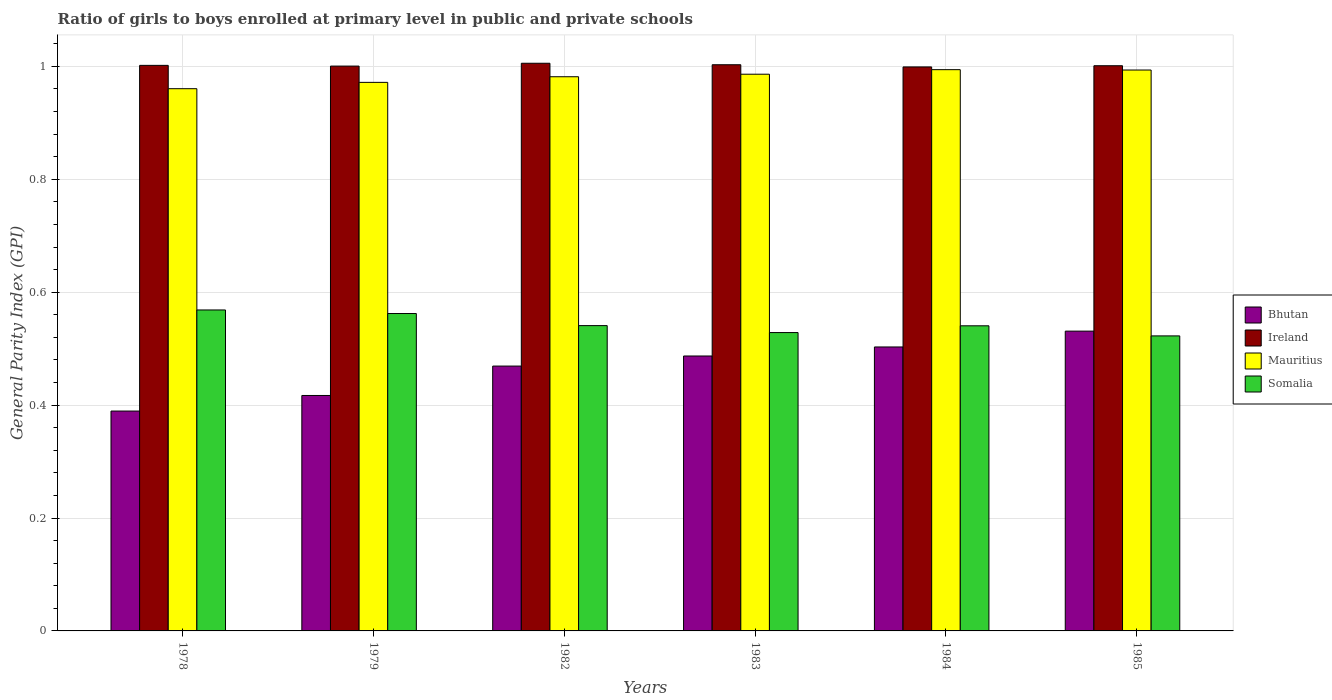How many groups of bars are there?
Keep it short and to the point. 6. How many bars are there on the 1st tick from the left?
Your response must be concise. 4. How many bars are there on the 4th tick from the right?
Make the answer very short. 4. What is the label of the 1st group of bars from the left?
Provide a short and direct response. 1978. What is the general parity index in Mauritius in 1978?
Your response must be concise. 0.96. Across all years, what is the maximum general parity index in Somalia?
Make the answer very short. 0.57. Across all years, what is the minimum general parity index in Somalia?
Give a very brief answer. 0.52. In which year was the general parity index in Ireland maximum?
Ensure brevity in your answer.  1982. In which year was the general parity index in Bhutan minimum?
Ensure brevity in your answer.  1978. What is the total general parity index in Somalia in the graph?
Offer a terse response. 3.26. What is the difference between the general parity index in Bhutan in 1978 and that in 1982?
Provide a succinct answer. -0.08. What is the difference between the general parity index in Ireland in 1982 and the general parity index in Somalia in 1985?
Give a very brief answer. 0.48. What is the average general parity index in Ireland per year?
Keep it short and to the point. 1. In the year 1984, what is the difference between the general parity index in Bhutan and general parity index in Ireland?
Give a very brief answer. -0.5. What is the ratio of the general parity index in Ireland in 1978 to that in 1984?
Provide a short and direct response. 1. Is the difference between the general parity index in Bhutan in 1978 and 1984 greater than the difference between the general parity index in Ireland in 1978 and 1984?
Make the answer very short. No. What is the difference between the highest and the second highest general parity index in Ireland?
Provide a short and direct response. 0. What is the difference between the highest and the lowest general parity index in Bhutan?
Keep it short and to the point. 0.14. In how many years, is the general parity index in Ireland greater than the average general parity index in Ireland taken over all years?
Your answer should be very brief. 2. Is it the case that in every year, the sum of the general parity index in Ireland and general parity index in Mauritius is greater than the sum of general parity index in Somalia and general parity index in Bhutan?
Keep it short and to the point. No. What does the 3rd bar from the left in 1979 represents?
Provide a succinct answer. Mauritius. What does the 2nd bar from the right in 1983 represents?
Your response must be concise. Mauritius. Is it the case that in every year, the sum of the general parity index in Ireland and general parity index in Mauritius is greater than the general parity index in Bhutan?
Keep it short and to the point. Yes. How many bars are there?
Offer a very short reply. 24. Are all the bars in the graph horizontal?
Make the answer very short. No. How many years are there in the graph?
Your answer should be compact. 6. Does the graph contain grids?
Offer a terse response. Yes. How are the legend labels stacked?
Ensure brevity in your answer.  Vertical. What is the title of the graph?
Ensure brevity in your answer.  Ratio of girls to boys enrolled at primary level in public and private schools. What is the label or title of the Y-axis?
Your response must be concise. General Parity Index (GPI). What is the General Parity Index (GPI) of Bhutan in 1978?
Offer a terse response. 0.39. What is the General Parity Index (GPI) in Ireland in 1978?
Provide a short and direct response. 1. What is the General Parity Index (GPI) of Mauritius in 1978?
Your answer should be compact. 0.96. What is the General Parity Index (GPI) in Somalia in 1978?
Ensure brevity in your answer.  0.57. What is the General Parity Index (GPI) of Bhutan in 1979?
Keep it short and to the point. 0.42. What is the General Parity Index (GPI) of Ireland in 1979?
Your answer should be very brief. 1. What is the General Parity Index (GPI) in Mauritius in 1979?
Offer a terse response. 0.97. What is the General Parity Index (GPI) in Somalia in 1979?
Give a very brief answer. 0.56. What is the General Parity Index (GPI) in Bhutan in 1982?
Make the answer very short. 0.47. What is the General Parity Index (GPI) in Ireland in 1982?
Your answer should be very brief. 1.01. What is the General Parity Index (GPI) of Mauritius in 1982?
Your answer should be very brief. 0.98. What is the General Parity Index (GPI) of Somalia in 1982?
Provide a succinct answer. 0.54. What is the General Parity Index (GPI) of Bhutan in 1983?
Your answer should be very brief. 0.49. What is the General Parity Index (GPI) of Ireland in 1983?
Your answer should be very brief. 1. What is the General Parity Index (GPI) of Mauritius in 1983?
Provide a succinct answer. 0.99. What is the General Parity Index (GPI) in Somalia in 1983?
Your response must be concise. 0.53. What is the General Parity Index (GPI) in Bhutan in 1984?
Ensure brevity in your answer.  0.5. What is the General Parity Index (GPI) of Ireland in 1984?
Your response must be concise. 1. What is the General Parity Index (GPI) of Mauritius in 1984?
Keep it short and to the point. 0.99. What is the General Parity Index (GPI) in Somalia in 1984?
Offer a very short reply. 0.54. What is the General Parity Index (GPI) of Bhutan in 1985?
Your answer should be compact. 0.53. What is the General Parity Index (GPI) of Ireland in 1985?
Keep it short and to the point. 1. What is the General Parity Index (GPI) of Mauritius in 1985?
Give a very brief answer. 0.99. What is the General Parity Index (GPI) of Somalia in 1985?
Your answer should be compact. 0.52. Across all years, what is the maximum General Parity Index (GPI) in Bhutan?
Your answer should be compact. 0.53. Across all years, what is the maximum General Parity Index (GPI) in Ireland?
Your response must be concise. 1.01. Across all years, what is the maximum General Parity Index (GPI) in Mauritius?
Make the answer very short. 0.99. Across all years, what is the maximum General Parity Index (GPI) of Somalia?
Keep it short and to the point. 0.57. Across all years, what is the minimum General Parity Index (GPI) in Bhutan?
Provide a short and direct response. 0.39. Across all years, what is the minimum General Parity Index (GPI) in Ireland?
Make the answer very short. 1. Across all years, what is the minimum General Parity Index (GPI) in Mauritius?
Your answer should be compact. 0.96. Across all years, what is the minimum General Parity Index (GPI) in Somalia?
Offer a terse response. 0.52. What is the total General Parity Index (GPI) of Bhutan in the graph?
Your answer should be compact. 2.8. What is the total General Parity Index (GPI) in Ireland in the graph?
Give a very brief answer. 6.01. What is the total General Parity Index (GPI) in Mauritius in the graph?
Ensure brevity in your answer.  5.89. What is the total General Parity Index (GPI) in Somalia in the graph?
Your answer should be very brief. 3.26. What is the difference between the General Parity Index (GPI) of Bhutan in 1978 and that in 1979?
Make the answer very short. -0.03. What is the difference between the General Parity Index (GPI) of Ireland in 1978 and that in 1979?
Ensure brevity in your answer.  0. What is the difference between the General Parity Index (GPI) of Mauritius in 1978 and that in 1979?
Offer a terse response. -0.01. What is the difference between the General Parity Index (GPI) of Somalia in 1978 and that in 1979?
Your answer should be very brief. 0.01. What is the difference between the General Parity Index (GPI) in Bhutan in 1978 and that in 1982?
Offer a very short reply. -0.08. What is the difference between the General Parity Index (GPI) in Ireland in 1978 and that in 1982?
Provide a succinct answer. -0. What is the difference between the General Parity Index (GPI) in Mauritius in 1978 and that in 1982?
Ensure brevity in your answer.  -0.02. What is the difference between the General Parity Index (GPI) of Somalia in 1978 and that in 1982?
Your response must be concise. 0.03. What is the difference between the General Parity Index (GPI) in Bhutan in 1978 and that in 1983?
Ensure brevity in your answer.  -0.1. What is the difference between the General Parity Index (GPI) in Ireland in 1978 and that in 1983?
Ensure brevity in your answer.  -0. What is the difference between the General Parity Index (GPI) of Mauritius in 1978 and that in 1983?
Make the answer very short. -0.03. What is the difference between the General Parity Index (GPI) in Bhutan in 1978 and that in 1984?
Your response must be concise. -0.11. What is the difference between the General Parity Index (GPI) in Ireland in 1978 and that in 1984?
Offer a very short reply. 0. What is the difference between the General Parity Index (GPI) of Mauritius in 1978 and that in 1984?
Your answer should be compact. -0.03. What is the difference between the General Parity Index (GPI) in Somalia in 1978 and that in 1984?
Your response must be concise. 0.03. What is the difference between the General Parity Index (GPI) in Bhutan in 1978 and that in 1985?
Provide a succinct answer. -0.14. What is the difference between the General Parity Index (GPI) in Ireland in 1978 and that in 1985?
Your response must be concise. 0. What is the difference between the General Parity Index (GPI) in Mauritius in 1978 and that in 1985?
Your answer should be very brief. -0.03. What is the difference between the General Parity Index (GPI) in Somalia in 1978 and that in 1985?
Provide a short and direct response. 0.05. What is the difference between the General Parity Index (GPI) of Bhutan in 1979 and that in 1982?
Offer a terse response. -0.05. What is the difference between the General Parity Index (GPI) of Ireland in 1979 and that in 1982?
Provide a short and direct response. -0.01. What is the difference between the General Parity Index (GPI) in Mauritius in 1979 and that in 1982?
Give a very brief answer. -0.01. What is the difference between the General Parity Index (GPI) of Somalia in 1979 and that in 1982?
Give a very brief answer. 0.02. What is the difference between the General Parity Index (GPI) in Bhutan in 1979 and that in 1983?
Provide a short and direct response. -0.07. What is the difference between the General Parity Index (GPI) of Ireland in 1979 and that in 1983?
Your answer should be very brief. -0. What is the difference between the General Parity Index (GPI) in Mauritius in 1979 and that in 1983?
Your answer should be very brief. -0.01. What is the difference between the General Parity Index (GPI) of Somalia in 1979 and that in 1983?
Your answer should be compact. 0.03. What is the difference between the General Parity Index (GPI) in Bhutan in 1979 and that in 1984?
Make the answer very short. -0.09. What is the difference between the General Parity Index (GPI) in Ireland in 1979 and that in 1984?
Make the answer very short. 0. What is the difference between the General Parity Index (GPI) in Mauritius in 1979 and that in 1984?
Your response must be concise. -0.02. What is the difference between the General Parity Index (GPI) in Somalia in 1979 and that in 1984?
Give a very brief answer. 0.02. What is the difference between the General Parity Index (GPI) in Bhutan in 1979 and that in 1985?
Your answer should be very brief. -0.11. What is the difference between the General Parity Index (GPI) in Ireland in 1979 and that in 1985?
Offer a very short reply. -0. What is the difference between the General Parity Index (GPI) of Mauritius in 1979 and that in 1985?
Your answer should be very brief. -0.02. What is the difference between the General Parity Index (GPI) of Somalia in 1979 and that in 1985?
Give a very brief answer. 0.04. What is the difference between the General Parity Index (GPI) in Bhutan in 1982 and that in 1983?
Give a very brief answer. -0.02. What is the difference between the General Parity Index (GPI) in Ireland in 1982 and that in 1983?
Your answer should be very brief. 0. What is the difference between the General Parity Index (GPI) in Mauritius in 1982 and that in 1983?
Ensure brevity in your answer.  -0. What is the difference between the General Parity Index (GPI) in Somalia in 1982 and that in 1983?
Your answer should be very brief. 0.01. What is the difference between the General Parity Index (GPI) of Bhutan in 1982 and that in 1984?
Offer a very short reply. -0.03. What is the difference between the General Parity Index (GPI) of Ireland in 1982 and that in 1984?
Offer a very short reply. 0.01. What is the difference between the General Parity Index (GPI) of Mauritius in 1982 and that in 1984?
Give a very brief answer. -0.01. What is the difference between the General Parity Index (GPI) of Bhutan in 1982 and that in 1985?
Your answer should be compact. -0.06. What is the difference between the General Parity Index (GPI) in Ireland in 1982 and that in 1985?
Keep it short and to the point. 0. What is the difference between the General Parity Index (GPI) in Mauritius in 1982 and that in 1985?
Provide a short and direct response. -0.01. What is the difference between the General Parity Index (GPI) of Somalia in 1982 and that in 1985?
Your response must be concise. 0.02. What is the difference between the General Parity Index (GPI) in Bhutan in 1983 and that in 1984?
Your answer should be very brief. -0.02. What is the difference between the General Parity Index (GPI) in Ireland in 1983 and that in 1984?
Provide a succinct answer. 0. What is the difference between the General Parity Index (GPI) of Mauritius in 1983 and that in 1984?
Your answer should be compact. -0.01. What is the difference between the General Parity Index (GPI) in Somalia in 1983 and that in 1984?
Your answer should be compact. -0.01. What is the difference between the General Parity Index (GPI) in Bhutan in 1983 and that in 1985?
Your answer should be very brief. -0.04. What is the difference between the General Parity Index (GPI) of Ireland in 1983 and that in 1985?
Make the answer very short. 0. What is the difference between the General Parity Index (GPI) of Mauritius in 1983 and that in 1985?
Make the answer very short. -0.01. What is the difference between the General Parity Index (GPI) in Somalia in 1983 and that in 1985?
Offer a terse response. 0.01. What is the difference between the General Parity Index (GPI) of Bhutan in 1984 and that in 1985?
Offer a very short reply. -0.03. What is the difference between the General Parity Index (GPI) of Ireland in 1984 and that in 1985?
Make the answer very short. -0. What is the difference between the General Parity Index (GPI) of Mauritius in 1984 and that in 1985?
Your answer should be compact. 0. What is the difference between the General Parity Index (GPI) of Somalia in 1984 and that in 1985?
Your answer should be very brief. 0.02. What is the difference between the General Parity Index (GPI) in Bhutan in 1978 and the General Parity Index (GPI) in Ireland in 1979?
Offer a terse response. -0.61. What is the difference between the General Parity Index (GPI) of Bhutan in 1978 and the General Parity Index (GPI) of Mauritius in 1979?
Give a very brief answer. -0.58. What is the difference between the General Parity Index (GPI) of Bhutan in 1978 and the General Parity Index (GPI) of Somalia in 1979?
Your answer should be very brief. -0.17. What is the difference between the General Parity Index (GPI) in Ireland in 1978 and the General Parity Index (GPI) in Mauritius in 1979?
Your answer should be very brief. 0.03. What is the difference between the General Parity Index (GPI) in Ireland in 1978 and the General Parity Index (GPI) in Somalia in 1979?
Ensure brevity in your answer.  0.44. What is the difference between the General Parity Index (GPI) in Mauritius in 1978 and the General Parity Index (GPI) in Somalia in 1979?
Offer a very short reply. 0.4. What is the difference between the General Parity Index (GPI) in Bhutan in 1978 and the General Parity Index (GPI) in Ireland in 1982?
Keep it short and to the point. -0.62. What is the difference between the General Parity Index (GPI) of Bhutan in 1978 and the General Parity Index (GPI) of Mauritius in 1982?
Your answer should be very brief. -0.59. What is the difference between the General Parity Index (GPI) in Bhutan in 1978 and the General Parity Index (GPI) in Somalia in 1982?
Offer a very short reply. -0.15. What is the difference between the General Parity Index (GPI) in Ireland in 1978 and the General Parity Index (GPI) in Mauritius in 1982?
Offer a terse response. 0.02. What is the difference between the General Parity Index (GPI) in Ireland in 1978 and the General Parity Index (GPI) in Somalia in 1982?
Give a very brief answer. 0.46. What is the difference between the General Parity Index (GPI) in Mauritius in 1978 and the General Parity Index (GPI) in Somalia in 1982?
Give a very brief answer. 0.42. What is the difference between the General Parity Index (GPI) in Bhutan in 1978 and the General Parity Index (GPI) in Ireland in 1983?
Offer a terse response. -0.61. What is the difference between the General Parity Index (GPI) of Bhutan in 1978 and the General Parity Index (GPI) of Mauritius in 1983?
Provide a short and direct response. -0.6. What is the difference between the General Parity Index (GPI) of Bhutan in 1978 and the General Parity Index (GPI) of Somalia in 1983?
Keep it short and to the point. -0.14. What is the difference between the General Parity Index (GPI) in Ireland in 1978 and the General Parity Index (GPI) in Mauritius in 1983?
Your answer should be very brief. 0.02. What is the difference between the General Parity Index (GPI) in Ireland in 1978 and the General Parity Index (GPI) in Somalia in 1983?
Ensure brevity in your answer.  0.47. What is the difference between the General Parity Index (GPI) of Mauritius in 1978 and the General Parity Index (GPI) of Somalia in 1983?
Your answer should be compact. 0.43. What is the difference between the General Parity Index (GPI) in Bhutan in 1978 and the General Parity Index (GPI) in Ireland in 1984?
Give a very brief answer. -0.61. What is the difference between the General Parity Index (GPI) of Bhutan in 1978 and the General Parity Index (GPI) of Mauritius in 1984?
Make the answer very short. -0.6. What is the difference between the General Parity Index (GPI) in Bhutan in 1978 and the General Parity Index (GPI) in Somalia in 1984?
Offer a terse response. -0.15. What is the difference between the General Parity Index (GPI) of Ireland in 1978 and the General Parity Index (GPI) of Mauritius in 1984?
Provide a short and direct response. 0.01. What is the difference between the General Parity Index (GPI) in Ireland in 1978 and the General Parity Index (GPI) in Somalia in 1984?
Your answer should be compact. 0.46. What is the difference between the General Parity Index (GPI) in Mauritius in 1978 and the General Parity Index (GPI) in Somalia in 1984?
Provide a short and direct response. 0.42. What is the difference between the General Parity Index (GPI) of Bhutan in 1978 and the General Parity Index (GPI) of Ireland in 1985?
Offer a terse response. -0.61. What is the difference between the General Parity Index (GPI) of Bhutan in 1978 and the General Parity Index (GPI) of Mauritius in 1985?
Make the answer very short. -0.6. What is the difference between the General Parity Index (GPI) of Bhutan in 1978 and the General Parity Index (GPI) of Somalia in 1985?
Ensure brevity in your answer.  -0.13. What is the difference between the General Parity Index (GPI) of Ireland in 1978 and the General Parity Index (GPI) of Mauritius in 1985?
Give a very brief answer. 0.01. What is the difference between the General Parity Index (GPI) of Ireland in 1978 and the General Parity Index (GPI) of Somalia in 1985?
Make the answer very short. 0.48. What is the difference between the General Parity Index (GPI) of Mauritius in 1978 and the General Parity Index (GPI) of Somalia in 1985?
Offer a very short reply. 0.44. What is the difference between the General Parity Index (GPI) in Bhutan in 1979 and the General Parity Index (GPI) in Ireland in 1982?
Make the answer very short. -0.59. What is the difference between the General Parity Index (GPI) of Bhutan in 1979 and the General Parity Index (GPI) of Mauritius in 1982?
Your answer should be very brief. -0.56. What is the difference between the General Parity Index (GPI) in Bhutan in 1979 and the General Parity Index (GPI) in Somalia in 1982?
Offer a terse response. -0.12. What is the difference between the General Parity Index (GPI) in Ireland in 1979 and the General Parity Index (GPI) in Mauritius in 1982?
Offer a terse response. 0.02. What is the difference between the General Parity Index (GPI) of Ireland in 1979 and the General Parity Index (GPI) of Somalia in 1982?
Provide a short and direct response. 0.46. What is the difference between the General Parity Index (GPI) in Mauritius in 1979 and the General Parity Index (GPI) in Somalia in 1982?
Ensure brevity in your answer.  0.43. What is the difference between the General Parity Index (GPI) of Bhutan in 1979 and the General Parity Index (GPI) of Ireland in 1983?
Keep it short and to the point. -0.59. What is the difference between the General Parity Index (GPI) of Bhutan in 1979 and the General Parity Index (GPI) of Mauritius in 1983?
Make the answer very short. -0.57. What is the difference between the General Parity Index (GPI) in Bhutan in 1979 and the General Parity Index (GPI) in Somalia in 1983?
Keep it short and to the point. -0.11. What is the difference between the General Parity Index (GPI) of Ireland in 1979 and the General Parity Index (GPI) of Mauritius in 1983?
Ensure brevity in your answer.  0.01. What is the difference between the General Parity Index (GPI) of Ireland in 1979 and the General Parity Index (GPI) of Somalia in 1983?
Give a very brief answer. 0.47. What is the difference between the General Parity Index (GPI) in Mauritius in 1979 and the General Parity Index (GPI) in Somalia in 1983?
Keep it short and to the point. 0.44. What is the difference between the General Parity Index (GPI) of Bhutan in 1979 and the General Parity Index (GPI) of Ireland in 1984?
Make the answer very short. -0.58. What is the difference between the General Parity Index (GPI) in Bhutan in 1979 and the General Parity Index (GPI) in Mauritius in 1984?
Your response must be concise. -0.58. What is the difference between the General Parity Index (GPI) in Bhutan in 1979 and the General Parity Index (GPI) in Somalia in 1984?
Provide a succinct answer. -0.12. What is the difference between the General Parity Index (GPI) in Ireland in 1979 and the General Parity Index (GPI) in Mauritius in 1984?
Keep it short and to the point. 0.01. What is the difference between the General Parity Index (GPI) of Ireland in 1979 and the General Parity Index (GPI) of Somalia in 1984?
Ensure brevity in your answer.  0.46. What is the difference between the General Parity Index (GPI) in Mauritius in 1979 and the General Parity Index (GPI) in Somalia in 1984?
Provide a short and direct response. 0.43. What is the difference between the General Parity Index (GPI) of Bhutan in 1979 and the General Parity Index (GPI) of Ireland in 1985?
Your answer should be compact. -0.58. What is the difference between the General Parity Index (GPI) in Bhutan in 1979 and the General Parity Index (GPI) in Mauritius in 1985?
Offer a terse response. -0.58. What is the difference between the General Parity Index (GPI) in Bhutan in 1979 and the General Parity Index (GPI) in Somalia in 1985?
Your answer should be compact. -0.11. What is the difference between the General Parity Index (GPI) of Ireland in 1979 and the General Parity Index (GPI) of Mauritius in 1985?
Ensure brevity in your answer.  0.01. What is the difference between the General Parity Index (GPI) in Ireland in 1979 and the General Parity Index (GPI) in Somalia in 1985?
Your response must be concise. 0.48. What is the difference between the General Parity Index (GPI) of Mauritius in 1979 and the General Parity Index (GPI) of Somalia in 1985?
Offer a very short reply. 0.45. What is the difference between the General Parity Index (GPI) in Bhutan in 1982 and the General Parity Index (GPI) in Ireland in 1983?
Keep it short and to the point. -0.53. What is the difference between the General Parity Index (GPI) in Bhutan in 1982 and the General Parity Index (GPI) in Mauritius in 1983?
Offer a terse response. -0.52. What is the difference between the General Parity Index (GPI) of Bhutan in 1982 and the General Parity Index (GPI) of Somalia in 1983?
Ensure brevity in your answer.  -0.06. What is the difference between the General Parity Index (GPI) in Ireland in 1982 and the General Parity Index (GPI) in Mauritius in 1983?
Ensure brevity in your answer.  0.02. What is the difference between the General Parity Index (GPI) in Ireland in 1982 and the General Parity Index (GPI) in Somalia in 1983?
Provide a succinct answer. 0.48. What is the difference between the General Parity Index (GPI) of Mauritius in 1982 and the General Parity Index (GPI) of Somalia in 1983?
Ensure brevity in your answer.  0.45. What is the difference between the General Parity Index (GPI) in Bhutan in 1982 and the General Parity Index (GPI) in Ireland in 1984?
Your answer should be compact. -0.53. What is the difference between the General Parity Index (GPI) of Bhutan in 1982 and the General Parity Index (GPI) of Mauritius in 1984?
Ensure brevity in your answer.  -0.53. What is the difference between the General Parity Index (GPI) in Bhutan in 1982 and the General Parity Index (GPI) in Somalia in 1984?
Offer a very short reply. -0.07. What is the difference between the General Parity Index (GPI) of Ireland in 1982 and the General Parity Index (GPI) of Mauritius in 1984?
Provide a short and direct response. 0.01. What is the difference between the General Parity Index (GPI) in Ireland in 1982 and the General Parity Index (GPI) in Somalia in 1984?
Offer a very short reply. 0.47. What is the difference between the General Parity Index (GPI) of Mauritius in 1982 and the General Parity Index (GPI) of Somalia in 1984?
Provide a succinct answer. 0.44. What is the difference between the General Parity Index (GPI) of Bhutan in 1982 and the General Parity Index (GPI) of Ireland in 1985?
Give a very brief answer. -0.53. What is the difference between the General Parity Index (GPI) in Bhutan in 1982 and the General Parity Index (GPI) in Mauritius in 1985?
Provide a succinct answer. -0.52. What is the difference between the General Parity Index (GPI) of Bhutan in 1982 and the General Parity Index (GPI) of Somalia in 1985?
Your answer should be compact. -0.05. What is the difference between the General Parity Index (GPI) in Ireland in 1982 and the General Parity Index (GPI) in Mauritius in 1985?
Keep it short and to the point. 0.01. What is the difference between the General Parity Index (GPI) of Ireland in 1982 and the General Parity Index (GPI) of Somalia in 1985?
Provide a short and direct response. 0.48. What is the difference between the General Parity Index (GPI) of Mauritius in 1982 and the General Parity Index (GPI) of Somalia in 1985?
Make the answer very short. 0.46. What is the difference between the General Parity Index (GPI) of Bhutan in 1983 and the General Parity Index (GPI) of Ireland in 1984?
Provide a short and direct response. -0.51. What is the difference between the General Parity Index (GPI) of Bhutan in 1983 and the General Parity Index (GPI) of Mauritius in 1984?
Ensure brevity in your answer.  -0.51. What is the difference between the General Parity Index (GPI) of Bhutan in 1983 and the General Parity Index (GPI) of Somalia in 1984?
Your answer should be compact. -0.05. What is the difference between the General Parity Index (GPI) in Ireland in 1983 and the General Parity Index (GPI) in Mauritius in 1984?
Your answer should be very brief. 0.01. What is the difference between the General Parity Index (GPI) of Ireland in 1983 and the General Parity Index (GPI) of Somalia in 1984?
Ensure brevity in your answer.  0.46. What is the difference between the General Parity Index (GPI) in Mauritius in 1983 and the General Parity Index (GPI) in Somalia in 1984?
Your answer should be compact. 0.45. What is the difference between the General Parity Index (GPI) in Bhutan in 1983 and the General Parity Index (GPI) in Ireland in 1985?
Provide a succinct answer. -0.51. What is the difference between the General Parity Index (GPI) of Bhutan in 1983 and the General Parity Index (GPI) of Mauritius in 1985?
Offer a very short reply. -0.51. What is the difference between the General Parity Index (GPI) of Bhutan in 1983 and the General Parity Index (GPI) of Somalia in 1985?
Provide a short and direct response. -0.04. What is the difference between the General Parity Index (GPI) in Ireland in 1983 and the General Parity Index (GPI) in Mauritius in 1985?
Your answer should be compact. 0.01. What is the difference between the General Parity Index (GPI) of Ireland in 1983 and the General Parity Index (GPI) of Somalia in 1985?
Provide a short and direct response. 0.48. What is the difference between the General Parity Index (GPI) of Mauritius in 1983 and the General Parity Index (GPI) of Somalia in 1985?
Make the answer very short. 0.46. What is the difference between the General Parity Index (GPI) in Bhutan in 1984 and the General Parity Index (GPI) in Ireland in 1985?
Your answer should be compact. -0.5. What is the difference between the General Parity Index (GPI) in Bhutan in 1984 and the General Parity Index (GPI) in Mauritius in 1985?
Make the answer very short. -0.49. What is the difference between the General Parity Index (GPI) in Bhutan in 1984 and the General Parity Index (GPI) in Somalia in 1985?
Offer a terse response. -0.02. What is the difference between the General Parity Index (GPI) of Ireland in 1984 and the General Parity Index (GPI) of Mauritius in 1985?
Ensure brevity in your answer.  0.01. What is the difference between the General Parity Index (GPI) in Ireland in 1984 and the General Parity Index (GPI) in Somalia in 1985?
Provide a short and direct response. 0.48. What is the difference between the General Parity Index (GPI) of Mauritius in 1984 and the General Parity Index (GPI) of Somalia in 1985?
Provide a succinct answer. 0.47. What is the average General Parity Index (GPI) in Bhutan per year?
Provide a short and direct response. 0.47. What is the average General Parity Index (GPI) of Ireland per year?
Your answer should be compact. 1. What is the average General Parity Index (GPI) of Mauritius per year?
Offer a terse response. 0.98. What is the average General Parity Index (GPI) in Somalia per year?
Ensure brevity in your answer.  0.54. In the year 1978, what is the difference between the General Parity Index (GPI) in Bhutan and General Parity Index (GPI) in Ireland?
Keep it short and to the point. -0.61. In the year 1978, what is the difference between the General Parity Index (GPI) in Bhutan and General Parity Index (GPI) in Mauritius?
Provide a short and direct response. -0.57. In the year 1978, what is the difference between the General Parity Index (GPI) in Bhutan and General Parity Index (GPI) in Somalia?
Your answer should be very brief. -0.18. In the year 1978, what is the difference between the General Parity Index (GPI) of Ireland and General Parity Index (GPI) of Mauritius?
Provide a short and direct response. 0.04. In the year 1978, what is the difference between the General Parity Index (GPI) of Ireland and General Parity Index (GPI) of Somalia?
Your response must be concise. 0.43. In the year 1978, what is the difference between the General Parity Index (GPI) in Mauritius and General Parity Index (GPI) in Somalia?
Your answer should be very brief. 0.39. In the year 1979, what is the difference between the General Parity Index (GPI) in Bhutan and General Parity Index (GPI) in Ireland?
Keep it short and to the point. -0.58. In the year 1979, what is the difference between the General Parity Index (GPI) in Bhutan and General Parity Index (GPI) in Mauritius?
Ensure brevity in your answer.  -0.55. In the year 1979, what is the difference between the General Parity Index (GPI) in Bhutan and General Parity Index (GPI) in Somalia?
Your answer should be very brief. -0.15. In the year 1979, what is the difference between the General Parity Index (GPI) of Ireland and General Parity Index (GPI) of Mauritius?
Ensure brevity in your answer.  0.03. In the year 1979, what is the difference between the General Parity Index (GPI) in Ireland and General Parity Index (GPI) in Somalia?
Your answer should be very brief. 0.44. In the year 1979, what is the difference between the General Parity Index (GPI) of Mauritius and General Parity Index (GPI) of Somalia?
Ensure brevity in your answer.  0.41. In the year 1982, what is the difference between the General Parity Index (GPI) in Bhutan and General Parity Index (GPI) in Ireland?
Your answer should be very brief. -0.54. In the year 1982, what is the difference between the General Parity Index (GPI) in Bhutan and General Parity Index (GPI) in Mauritius?
Give a very brief answer. -0.51. In the year 1982, what is the difference between the General Parity Index (GPI) in Bhutan and General Parity Index (GPI) in Somalia?
Your response must be concise. -0.07. In the year 1982, what is the difference between the General Parity Index (GPI) of Ireland and General Parity Index (GPI) of Mauritius?
Ensure brevity in your answer.  0.02. In the year 1982, what is the difference between the General Parity Index (GPI) in Ireland and General Parity Index (GPI) in Somalia?
Ensure brevity in your answer.  0.46. In the year 1982, what is the difference between the General Parity Index (GPI) in Mauritius and General Parity Index (GPI) in Somalia?
Give a very brief answer. 0.44. In the year 1983, what is the difference between the General Parity Index (GPI) in Bhutan and General Parity Index (GPI) in Ireland?
Provide a short and direct response. -0.52. In the year 1983, what is the difference between the General Parity Index (GPI) of Bhutan and General Parity Index (GPI) of Mauritius?
Make the answer very short. -0.5. In the year 1983, what is the difference between the General Parity Index (GPI) in Bhutan and General Parity Index (GPI) in Somalia?
Ensure brevity in your answer.  -0.04. In the year 1983, what is the difference between the General Parity Index (GPI) in Ireland and General Parity Index (GPI) in Mauritius?
Keep it short and to the point. 0.02. In the year 1983, what is the difference between the General Parity Index (GPI) of Ireland and General Parity Index (GPI) of Somalia?
Ensure brevity in your answer.  0.47. In the year 1983, what is the difference between the General Parity Index (GPI) in Mauritius and General Parity Index (GPI) in Somalia?
Give a very brief answer. 0.46. In the year 1984, what is the difference between the General Parity Index (GPI) of Bhutan and General Parity Index (GPI) of Ireland?
Keep it short and to the point. -0.5. In the year 1984, what is the difference between the General Parity Index (GPI) in Bhutan and General Parity Index (GPI) in Mauritius?
Offer a very short reply. -0.49. In the year 1984, what is the difference between the General Parity Index (GPI) in Bhutan and General Parity Index (GPI) in Somalia?
Your answer should be compact. -0.04. In the year 1984, what is the difference between the General Parity Index (GPI) of Ireland and General Parity Index (GPI) of Mauritius?
Give a very brief answer. 0. In the year 1984, what is the difference between the General Parity Index (GPI) of Ireland and General Parity Index (GPI) of Somalia?
Provide a short and direct response. 0.46. In the year 1984, what is the difference between the General Parity Index (GPI) in Mauritius and General Parity Index (GPI) in Somalia?
Your response must be concise. 0.45. In the year 1985, what is the difference between the General Parity Index (GPI) of Bhutan and General Parity Index (GPI) of Ireland?
Your response must be concise. -0.47. In the year 1985, what is the difference between the General Parity Index (GPI) in Bhutan and General Parity Index (GPI) in Mauritius?
Offer a terse response. -0.46. In the year 1985, what is the difference between the General Parity Index (GPI) in Bhutan and General Parity Index (GPI) in Somalia?
Make the answer very short. 0.01. In the year 1985, what is the difference between the General Parity Index (GPI) of Ireland and General Parity Index (GPI) of Mauritius?
Give a very brief answer. 0.01. In the year 1985, what is the difference between the General Parity Index (GPI) in Ireland and General Parity Index (GPI) in Somalia?
Offer a terse response. 0.48. In the year 1985, what is the difference between the General Parity Index (GPI) in Mauritius and General Parity Index (GPI) in Somalia?
Keep it short and to the point. 0.47. What is the ratio of the General Parity Index (GPI) in Bhutan in 1978 to that in 1979?
Make the answer very short. 0.93. What is the ratio of the General Parity Index (GPI) in Ireland in 1978 to that in 1979?
Make the answer very short. 1. What is the ratio of the General Parity Index (GPI) of Mauritius in 1978 to that in 1979?
Make the answer very short. 0.99. What is the ratio of the General Parity Index (GPI) of Somalia in 1978 to that in 1979?
Provide a succinct answer. 1.01. What is the ratio of the General Parity Index (GPI) of Bhutan in 1978 to that in 1982?
Keep it short and to the point. 0.83. What is the ratio of the General Parity Index (GPI) of Mauritius in 1978 to that in 1982?
Provide a succinct answer. 0.98. What is the ratio of the General Parity Index (GPI) of Somalia in 1978 to that in 1982?
Provide a succinct answer. 1.05. What is the ratio of the General Parity Index (GPI) of Bhutan in 1978 to that in 1983?
Offer a terse response. 0.8. What is the ratio of the General Parity Index (GPI) of Somalia in 1978 to that in 1983?
Ensure brevity in your answer.  1.08. What is the ratio of the General Parity Index (GPI) in Bhutan in 1978 to that in 1984?
Offer a terse response. 0.77. What is the ratio of the General Parity Index (GPI) in Ireland in 1978 to that in 1984?
Provide a short and direct response. 1. What is the ratio of the General Parity Index (GPI) of Mauritius in 1978 to that in 1984?
Your answer should be very brief. 0.97. What is the ratio of the General Parity Index (GPI) of Somalia in 1978 to that in 1984?
Offer a very short reply. 1.05. What is the ratio of the General Parity Index (GPI) of Bhutan in 1978 to that in 1985?
Offer a terse response. 0.73. What is the ratio of the General Parity Index (GPI) of Mauritius in 1978 to that in 1985?
Your response must be concise. 0.97. What is the ratio of the General Parity Index (GPI) of Somalia in 1978 to that in 1985?
Keep it short and to the point. 1.09. What is the ratio of the General Parity Index (GPI) of Bhutan in 1979 to that in 1982?
Your response must be concise. 0.89. What is the ratio of the General Parity Index (GPI) of Ireland in 1979 to that in 1982?
Ensure brevity in your answer.  0.99. What is the ratio of the General Parity Index (GPI) in Mauritius in 1979 to that in 1982?
Your answer should be very brief. 0.99. What is the ratio of the General Parity Index (GPI) in Somalia in 1979 to that in 1982?
Provide a succinct answer. 1.04. What is the ratio of the General Parity Index (GPI) in Bhutan in 1979 to that in 1983?
Keep it short and to the point. 0.86. What is the ratio of the General Parity Index (GPI) in Somalia in 1979 to that in 1983?
Offer a very short reply. 1.06. What is the ratio of the General Parity Index (GPI) in Bhutan in 1979 to that in 1984?
Your response must be concise. 0.83. What is the ratio of the General Parity Index (GPI) in Ireland in 1979 to that in 1984?
Your answer should be very brief. 1. What is the ratio of the General Parity Index (GPI) of Mauritius in 1979 to that in 1984?
Your answer should be very brief. 0.98. What is the ratio of the General Parity Index (GPI) of Somalia in 1979 to that in 1984?
Offer a very short reply. 1.04. What is the ratio of the General Parity Index (GPI) in Bhutan in 1979 to that in 1985?
Give a very brief answer. 0.79. What is the ratio of the General Parity Index (GPI) of Ireland in 1979 to that in 1985?
Offer a terse response. 1. What is the ratio of the General Parity Index (GPI) in Somalia in 1979 to that in 1985?
Give a very brief answer. 1.08. What is the ratio of the General Parity Index (GPI) of Bhutan in 1982 to that in 1983?
Your answer should be compact. 0.96. What is the ratio of the General Parity Index (GPI) of Mauritius in 1982 to that in 1983?
Make the answer very short. 1. What is the ratio of the General Parity Index (GPI) in Somalia in 1982 to that in 1983?
Keep it short and to the point. 1.02. What is the ratio of the General Parity Index (GPI) of Bhutan in 1982 to that in 1984?
Give a very brief answer. 0.93. What is the ratio of the General Parity Index (GPI) of Ireland in 1982 to that in 1984?
Provide a succinct answer. 1.01. What is the ratio of the General Parity Index (GPI) in Mauritius in 1982 to that in 1984?
Provide a short and direct response. 0.99. What is the ratio of the General Parity Index (GPI) in Bhutan in 1982 to that in 1985?
Ensure brevity in your answer.  0.88. What is the ratio of the General Parity Index (GPI) of Somalia in 1982 to that in 1985?
Make the answer very short. 1.03. What is the ratio of the General Parity Index (GPI) of Bhutan in 1983 to that in 1984?
Ensure brevity in your answer.  0.97. What is the ratio of the General Parity Index (GPI) in Ireland in 1983 to that in 1984?
Give a very brief answer. 1. What is the ratio of the General Parity Index (GPI) of Somalia in 1983 to that in 1984?
Keep it short and to the point. 0.98. What is the ratio of the General Parity Index (GPI) in Bhutan in 1983 to that in 1985?
Provide a short and direct response. 0.92. What is the ratio of the General Parity Index (GPI) in Mauritius in 1983 to that in 1985?
Provide a short and direct response. 0.99. What is the ratio of the General Parity Index (GPI) of Somalia in 1983 to that in 1985?
Ensure brevity in your answer.  1.01. What is the ratio of the General Parity Index (GPI) of Bhutan in 1984 to that in 1985?
Offer a very short reply. 0.95. What is the ratio of the General Parity Index (GPI) in Ireland in 1984 to that in 1985?
Your answer should be very brief. 1. What is the ratio of the General Parity Index (GPI) of Somalia in 1984 to that in 1985?
Offer a terse response. 1.03. What is the difference between the highest and the second highest General Parity Index (GPI) of Bhutan?
Make the answer very short. 0.03. What is the difference between the highest and the second highest General Parity Index (GPI) in Ireland?
Offer a very short reply. 0. What is the difference between the highest and the second highest General Parity Index (GPI) in Mauritius?
Your answer should be compact. 0. What is the difference between the highest and the second highest General Parity Index (GPI) of Somalia?
Ensure brevity in your answer.  0.01. What is the difference between the highest and the lowest General Parity Index (GPI) of Bhutan?
Offer a terse response. 0.14. What is the difference between the highest and the lowest General Parity Index (GPI) in Ireland?
Your response must be concise. 0.01. What is the difference between the highest and the lowest General Parity Index (GPI) of Mauritius?
Keep it short and to the point. 0.03. What is the difference between the highest and the lowest General Parity Index (GPI) of Somalia?
Give a very brief answer. 0.05. 